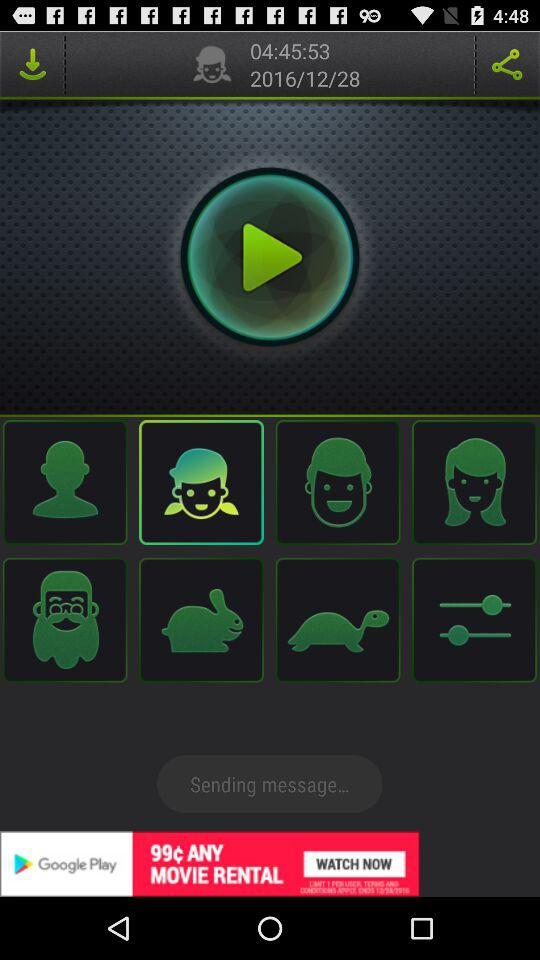Which applications are available for sharing?
When the provided information is insufficient, respond with <no answer>. <no answer> 